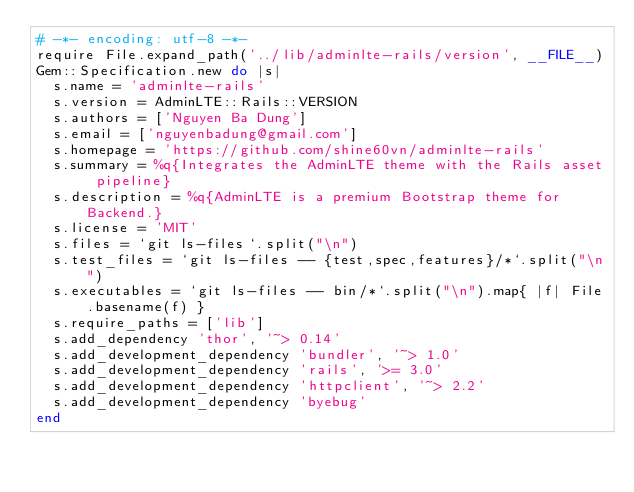Convert code to text. <code><loc_0><loc_0><loc_500><loc_500><_Ruby_># -*- encoding: utf-8 -*-
require File.expand_path('../lib/adminlte-rails/version', __FILE__)
Gem::Specification.new do |s|
  s.name = 'adminlte-rails'
  s.version = AdminLTE::Rails::VERSION
  s.authors = ['Nguyen Ba Dung']
  s.email = ['nguyenbadung@gmail.com']
  s.homepage = 'https://github.com/shine60vn/adminlte-rails'
  s.summary = %q{Integrates the AdminLTE theme with the Rails asset pipeline}
  s.description = %q{AdminLTE is a premium Bootstrap theme for Backend.}
  s.license = 'MIT'
  s.files = `git ls-files`.split("\n")
  s.test_files = `git ls-files -- {test,spec,features}/*`.split("\n")
  s.executables = `git ls-files -- bin/*`.split("\n").map{ |f| File.basename(f) }
  s.require_paths = ['lib']
  s.add_dependency 'thor', '~> 0.14'
  s.add_development_dependency 'bundler', '~> 1.0'
  s.add_development_dependency 'rails', '>= 3.0'
  s.add_development_dependency 'httpclient', '~> 2.2'
  s.add_development_dependency 'byebug'
end</code> 